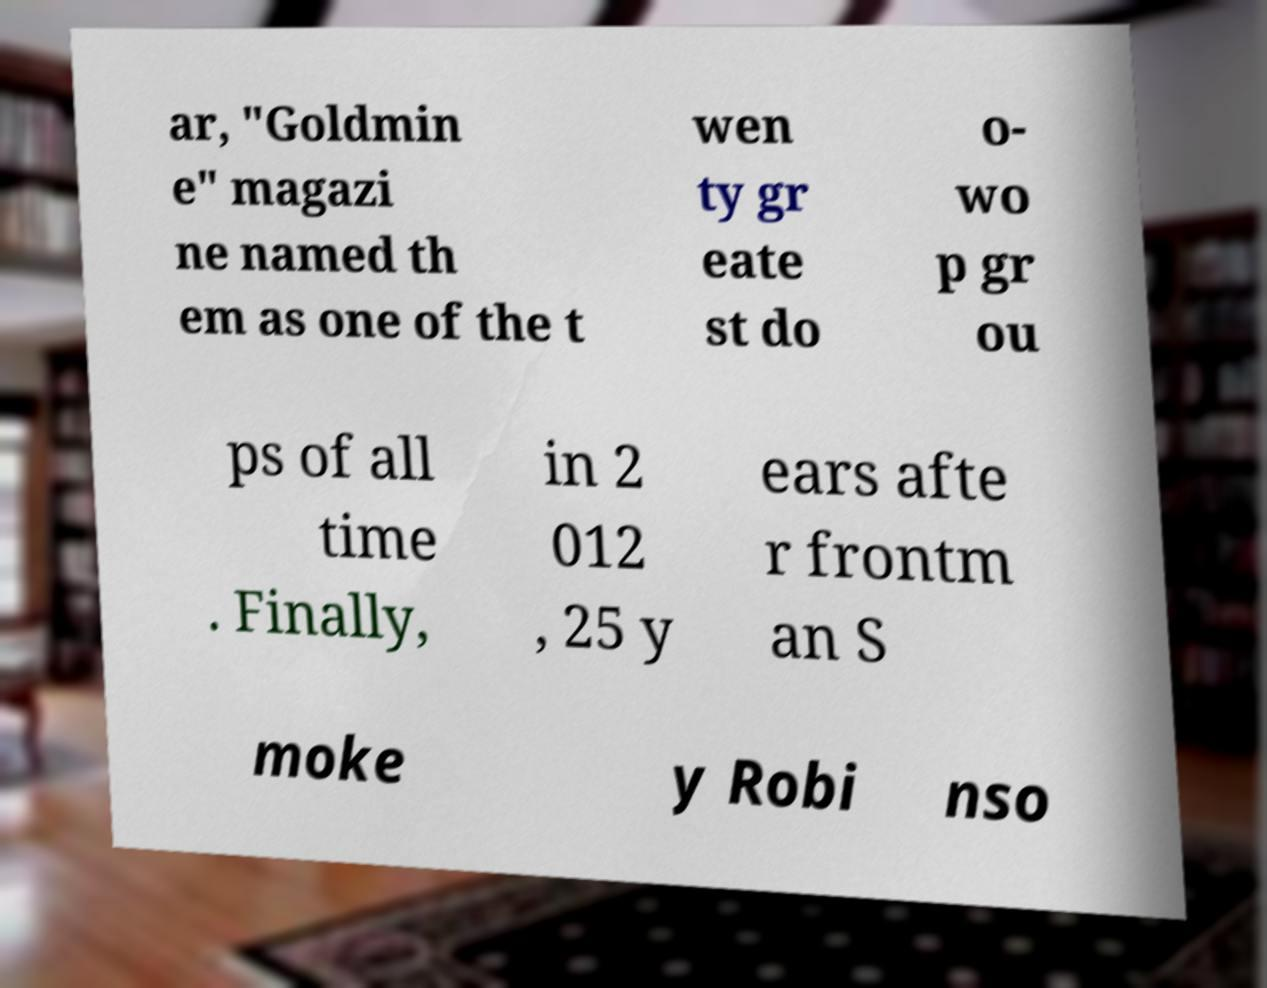Can you accurately transcribe the text from the provided image for me? ar, "Goldmin e" magazi ne named th em as one of the t wen ty gr eate st do o- wo p gr ou ps of all time . Finally, in 2 012 , 25 y ears afte r frontm an S moke y Robi nso 